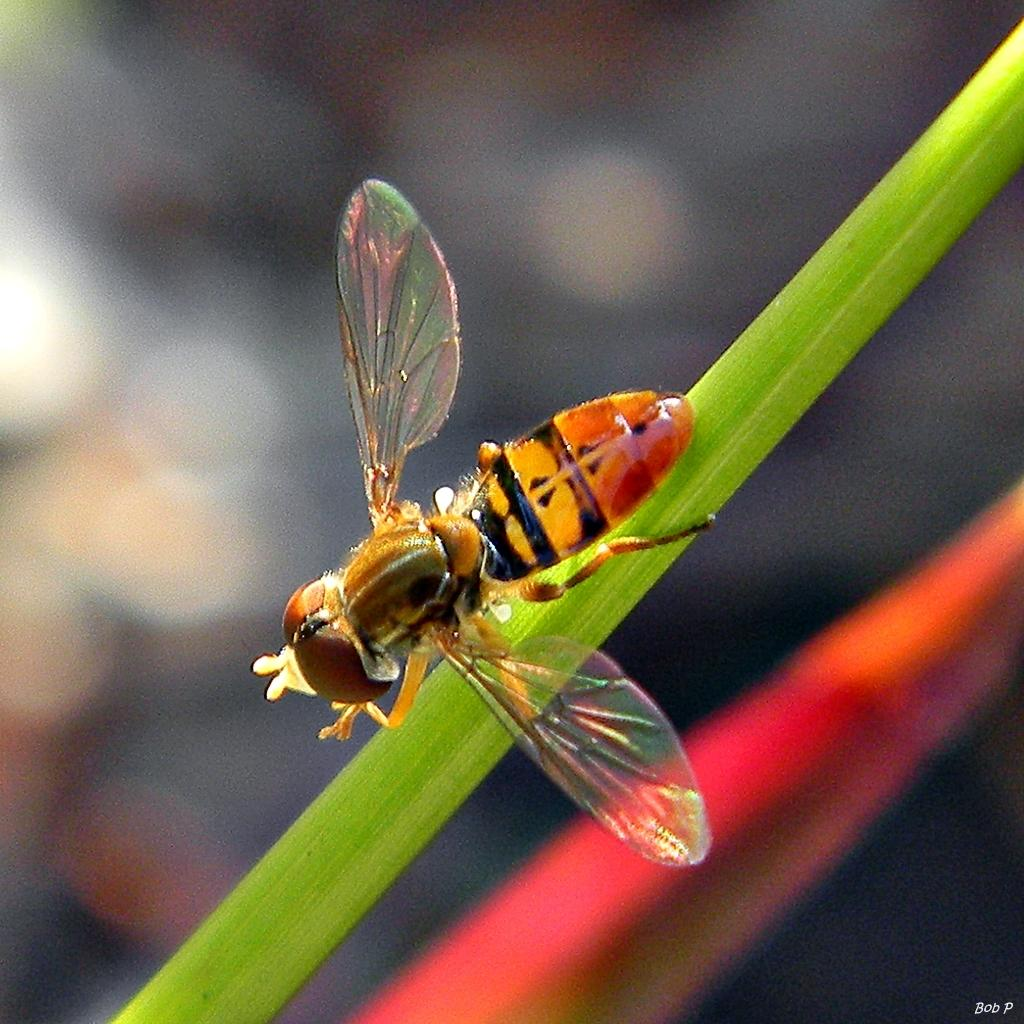What type of insect is in the image? There is a honey bee in the image. Where is the honey bee located? The honey bee is on a stem. What type of scissors can be seen cutting the bushes in the image? There are no scissors or bushes present in the image; it only features a honey bee on a stem. 